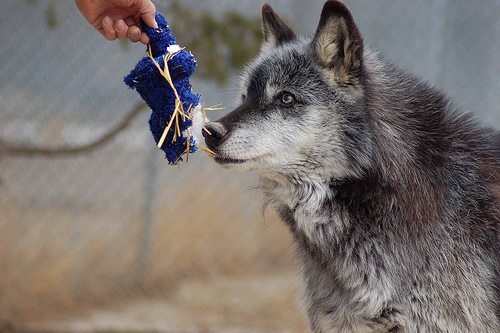<image>
Is there a toy next to the wolf? Yes. The toy is positioned adjacent to the wolf, located nearby in the same general area. 